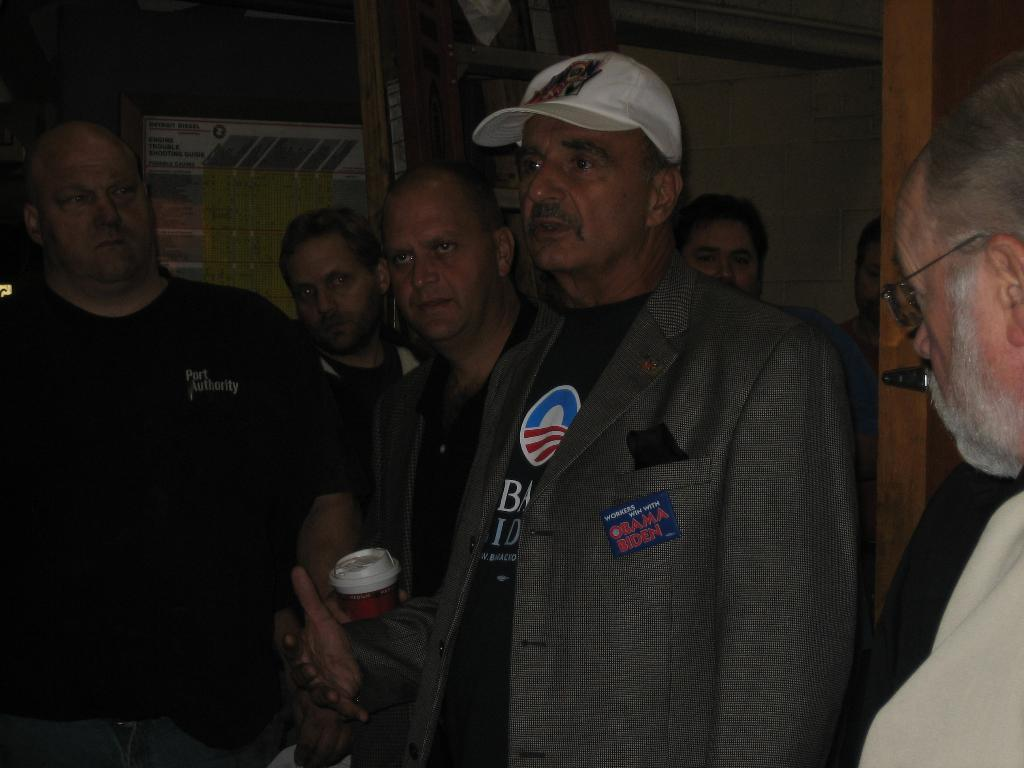How many people are in the image? There is a group of people standing in the image. What is one person in the group holding? There is a person holding a cup in the image. What can be seen in the background of the image? There is a wall in the background of the image. What verse is being recited by the beggar in the image? There is no beggar present in the image, and therefore no verse being recited. How many hens are visible in the image? There are no hens present in the image. 